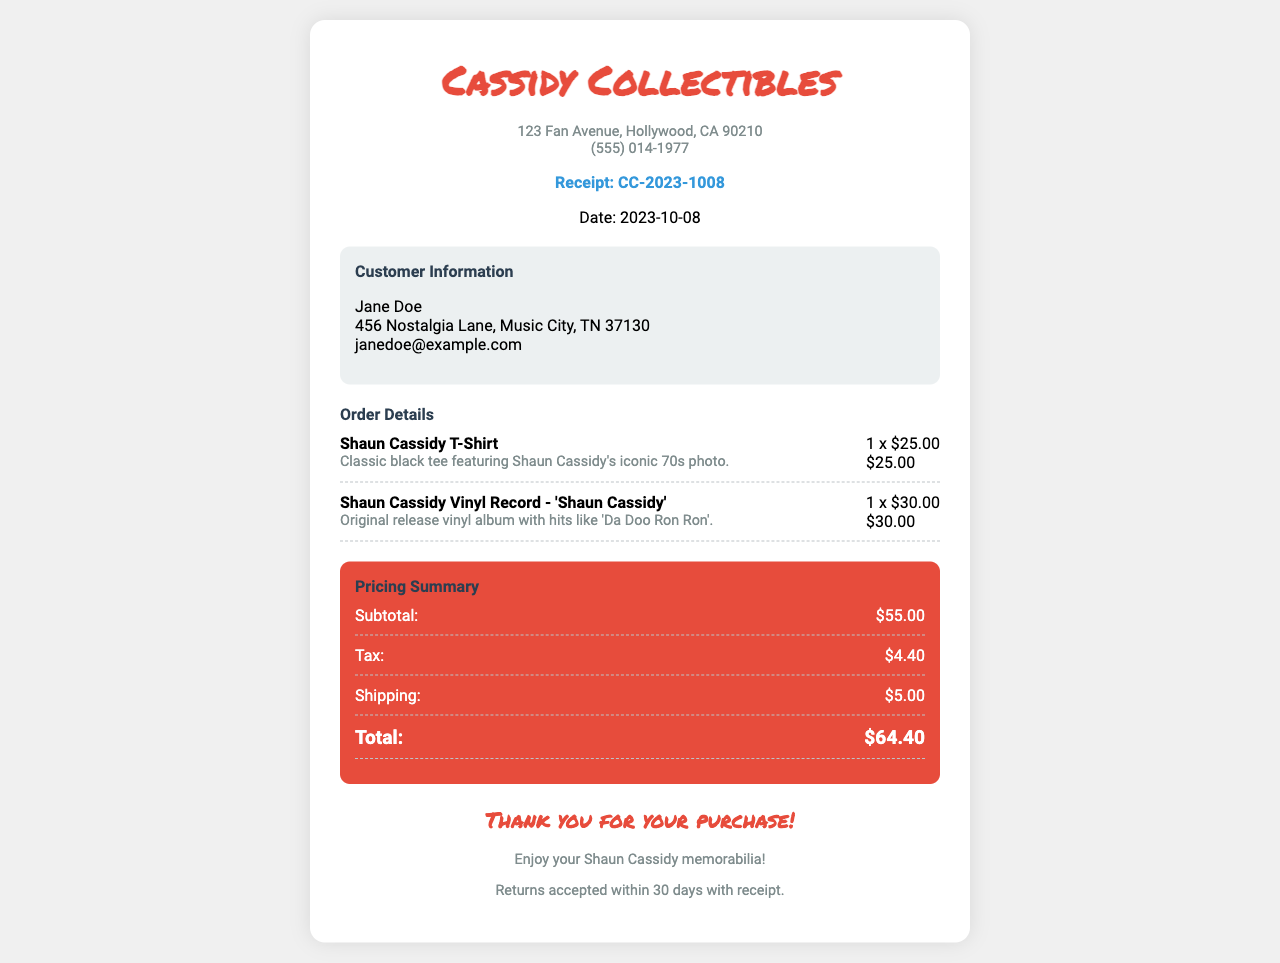What is the receipt number? The receipt number is prominently displayed in the document for identification purposes.
Answer: CC-2023-1008 What is the date of the order? The date of the order is clearly stated in the receipt details.
Answer: 2023-10-08 What are the names of the items purchased? The items purchased are listed in the order details section.
Answer: Shaun Cassidy T-Shirt, Shaun Cassidy Vinyl Record - 'Shaun Cassidy' What is the subtotal amount? The subtotal is calculated from the prices of the items before tax and shipping.
Answer: $55.00 What is the tax amount? The tax amount is listed separately in the pricing summary section.
Answer: $4.40 What is the total amount paid? The total amount includes the subtotal, tax, and shipping costs.
Answer: $64.40 What is the shipping fee? The shipping fee is mentioned in the pricing summary section of the document.
Answer: $5.00 What is the return policy? The return policy is stated at the bottom of the receipt for customer reference.
Answer: Returns accepted within 30 days with receipt Who is the customer? The customer information section provides the name of the person who made the purchase.
Answer: Jane Doe 